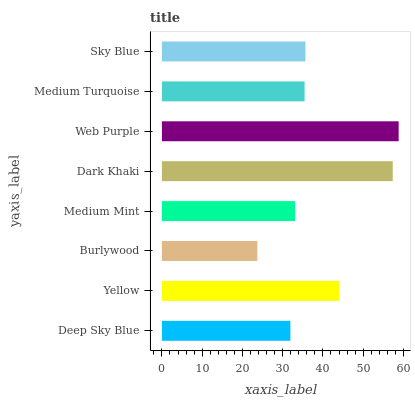Is Burlywood the minimum?
Answer yes or no. Yes. Is Web Purple the maximum?
Answer yes or no. Yes. Is Yellow the minimum?
Answer yes or no. No. Is Yellow the maximum?
Answer yes or no. No. Is Yellow greater than Deep Sky Blue?
Answer yes or no. Yes. Is Deep Sky Blue less than Yellow?
Answer yes or no. Yes. Is Deep Sky Blue greater than Yellow?
Answer yes or no. No. Is Yellow less than Deep Sky Blue?
Answer yes or no. No. Is Sky Blue the high median?
Answer yes or no. Yes. Is Medium Turquoise the low median?
Answer yes or no. Yes. Is Dark Khaki the high median?
Answer yes or no. No. Is Yellow the low median?
Answer yes or no. No. 